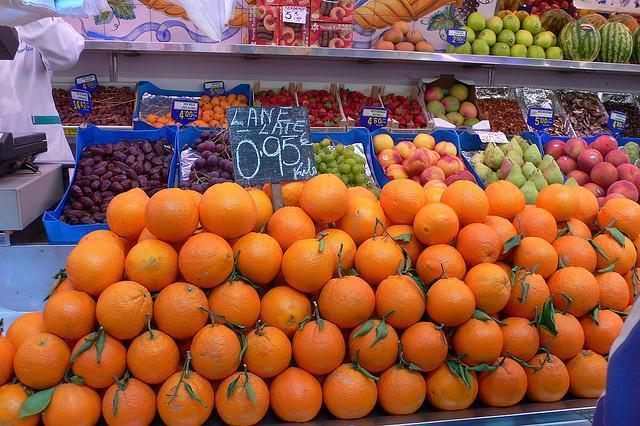How many oranges are in the picture?
Give a very brief answer. 3. How many people are there?
Give a very brief answer. 2. How many apples are in the photo?
Give a very brief answer. 2. 